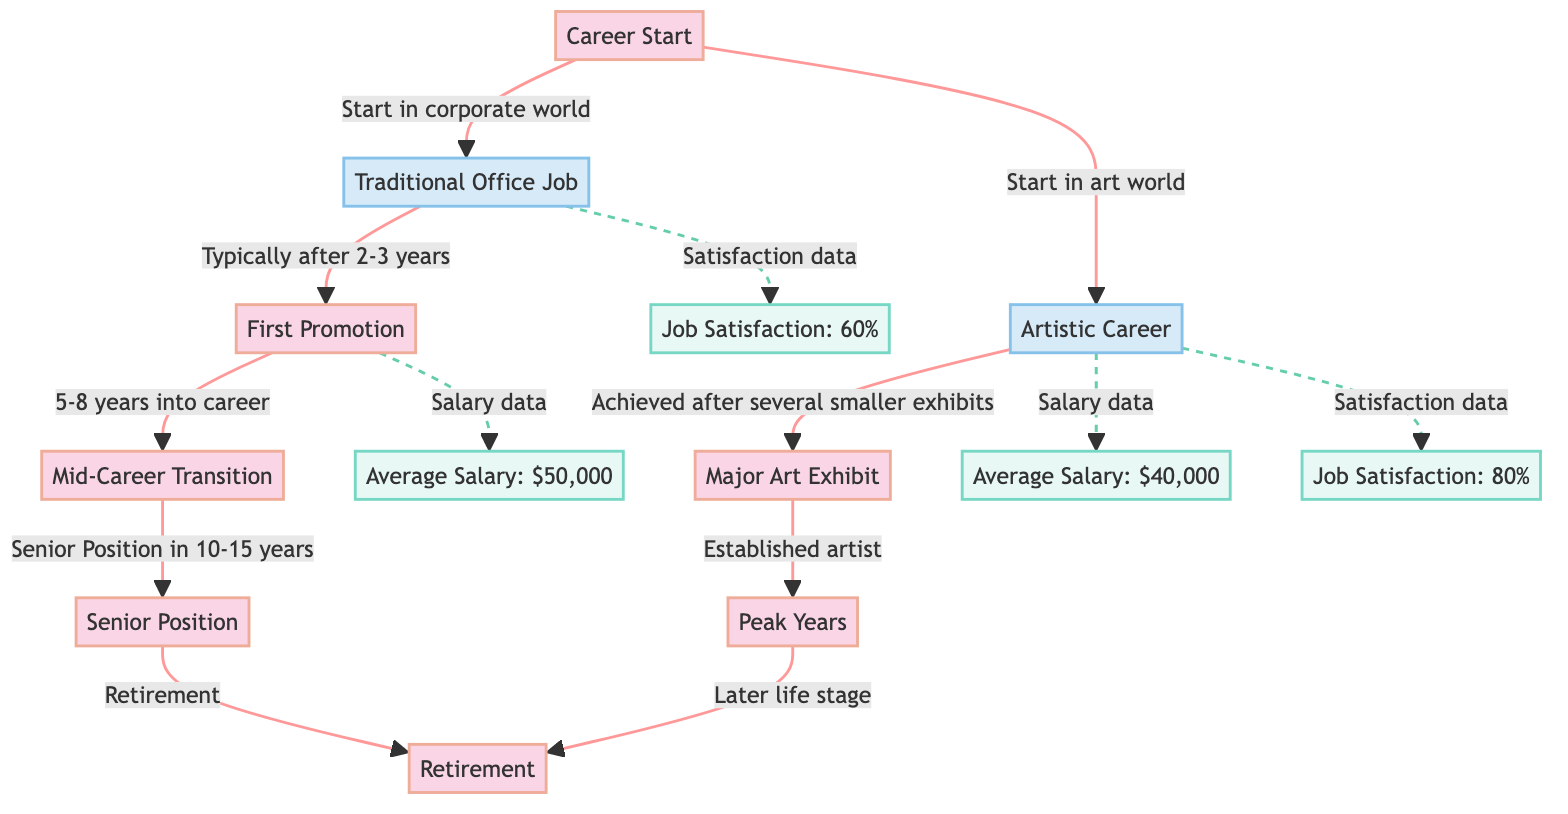What is the average salary for a traditional office job? The diagram explicitly states that the average salary for a traditional office job is listed as $50,000.
Answer: $50,000 What is the peak career milestone for an artistic career? The diagram indicates that the "Peak Years" is the milestone for artistic careers, which comes after "Major Art Exhibit."
Answer: Peak Years How many major milestones are shown for artistic careers? By counting the nodes pertaining to artistic careers, one can see there are three major milestones: "Career Start," "Major Art Exhibit," and "Peak Years."
Answer: 3 What is the job satisfaction level for artistic careers? The diagram provides that job satisfaction in artistic careers is 80%, as represented in the section detailing satisfaction data.
Answer: 80% At what average salary do traditional office jobs achieve "Senior Position"? The diagram reveals a dashed line from the "Senior Position" that points back to the average salary of $50,000, indicating that this average salary is pertinent for achieving a senior role in a traditional office job.
Answer: $50,000 What is the average salary difference between traditional office jobs and artistic careers? The average salary for traditional office jobs is $50,000, and for artistic careers, it is $40,000. Therefore, the difference is calculated as $50,000 - $40,000, resulting in a $10,000 difference.
Answer: $10,000 Which career path has a higher job satisfaction level? Comparing the job satisfaction levels from the diagram, artistic careers exhibit a job satisfaction level of 80%, whereas traditional office jobs show 60%. Since 80% is greater than 60%, artistic careers have a higher job satisfaction level.
Answer: Artistic Career How many years does it typically take to achieve the first promotion in a traditional office job? The diagram notes that the first promotion typically occurs after 2-3 years in a traditional office job, which is informative about the time frame for early career advancement.
Answer: 2-3 years What career milestone occurs after 5-8 years in a traditional office job? The diagram specifies that the "Mid-Career Transition" is achieved after 5-8 years in a traditional office job. This is directly referenced in the connections leading from "First Promotion."
Answer: Mid-Career Transition 